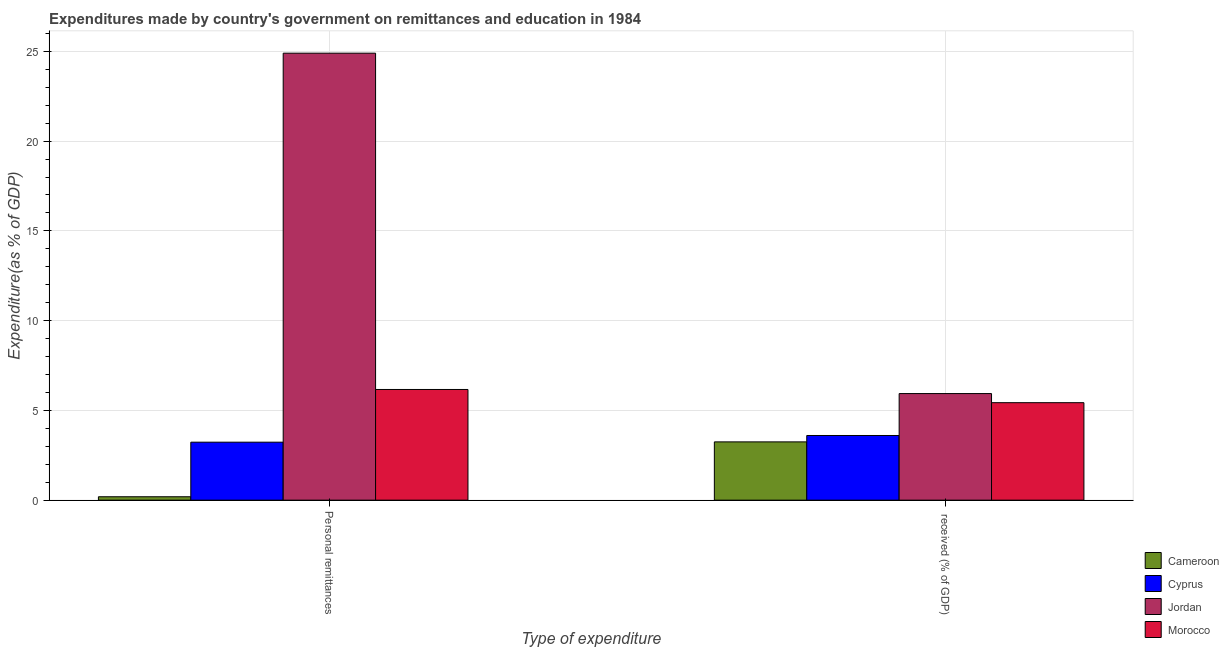Are the number of bars on each tick of the X-axis equal?
Ensure brevity in your answer.  Yes. What is the label of the 2nd group of bars from the left?
Your answer should be compact.  received (% of GDP). What is the expenditure in personal remittances in Jordan?
Offer a terse response. 24.9. Across all countries, what is the maximum expenditure in personal remittances?
Your response must be concise. 24.9. Across all countries, what is the minimum expenditure in personal remittances?
Provide a succinct answer. 0.19. In which country was the expenditure in personal remittances maximum?
Offer a terse response. Jordan. In which country was the expenditure in education minimum?
Offer a very short reply. Cameroon. What is the total expenditure in education in the graph?
Provide a succinct answer. 18.21. What is the difference between the expenditure in education in Cyprus and that in Morocco?
Your response must be concise. -1.83. What is the difference between the expenditure in education in Morocco and the expenditure in personal remittances in Cyprus?
Make the answer very short. 2.2. What is the average expenditure in education per country?
Ensure brevity in your answer.  4.55. What is the difference between the expenditure in personal remittances and expenditure in education in Morocco?
Keep it short and to the point. 0.74. What is the ratio of the expenditure in personal remittances in Cyprus to that in Jordan?
Your answer should be compact. 0.13. Is the expenditure in personal remittances in Cyprus less than that in Morocco?
Make the answer very short. Yes. What does the 1st bar from the left in  received (% of GDP) represents?
Give a very brief answer. Cameroon. What does the 4th bar from the right in Personal remittances represents?
Keep it short and to the point. Cameroon. Are the values on the major ticks of Y-axis written in scientific E-notation?
Your answer should be compact. No. Does the graph contain grids?
Give a very brief answer. Yes. Where does the legend appear in the graph?
Make the answer very short. Bottom right. How are the legend labels stacked?
Keep it short and to the point. Vertical. What is the title of the graph?
Your answer should be very brief. Expenditures made by country's government on remittances and education in 1984. What is the label or title of the X-axis?
Provide a succinct answer. Type of expenditure. What is the label or title of the Y-axis?
Offer a very short reply. Expenditure(as % of GDP). What is the Expenditure(as % of GDP) of Cameroon in Personal remittances?
Provide a succinct answer. 0.19. What is the Expenditure(as % of GDP) of Cyprus in Personal remittances?
Keep it short and to the point. 3.23. What is the Expenditure(as % of GDP) of Jordan in Personal remittances?
Give a very brief answer. 24.9. What is the Expenditure(as % of GDP) in Morocco in Personal remittances?
Provide a succinct answer. 6.17. What is the Expenditure(as % of GDP) in Cameroon in  received (% of GDP)?
Ensure brevity in your answer.  3.25. What is the Expenditure(as % of GDP) of Cyprus in  received (% of GDP)?
Your response must be concise. 3.6. What is the Expenditure(as % of GDP) in Jordan in  received (% of GDP)?
Give a very brief answer. 5.94. What is the Expenditure(as % of GDP) of Morocco in  received (% of GDP)?
Offer a very short reply. 5.43. Across all Type of expenditure, what is the maximum Expenditure(as % of GDP) in Cameroon?
Provide a succinct answer. 3.25. Across all Type of expenditure, what is the maximum Expenditure(as % of GDP) of Cyprus?
Provide a succinct answer. 3.6. Across all Type of expenditure, what is the maximum Expenditure(as % of GDP) of Jordan?
Give a very brief answer. 24.9. Across all Type of expenditure, what is the maximum Expenditure(as % of GDP) in Morocco?
Your response must be concise. 6.17. Across all Type of expenditure, what is the minimum Expenditure(as % of GDP) in Cameroon?
Offer a terse response. 0.19. Across all Type of expenditure, what is the minimum Expenditure(as % of GDP) of Cyprus?
Provide a short and direct response. 3.23. Across all Type of expenditure, what is the minimum Expenditure(as % of GDP) of Jordan?
Keep it short and to the point. 5.94. Across all Type of expenditure, what is the minimum Expenditure(as % of GDP) of Morocco?
Your response must be concise. 5.43. What is the total Expenditure(as % of GDP) in Cameroon in the graph?
Offer a terse response. 3.44. What is the total Expenditure(as % of GDP) of Cyprus in the graph?
Provide a short and direct response. 6.83. What is the total Expenditure(as % of GDP) in Jordan in the graph?
Provide a succinct answer. 30.83. What is the total Expenditure(as % of GDP) in Morocco in the graph?
Provide a succinct answer. 11.6. What is the difference between the Expenditure(as % of GDP) in Cameroon in Personal remittances and that in  received (% of GDP)?
Offer a terse response. -3.06. What is the difference between the Expenditure(as % of GDP) in Cyprus in Personal remittances and that in  received (% of GDP)?
Provide a succinct answer. -0.37. What is the difference between the Expenditure(as % of GDP) in Jordan in Personal remittances and that in  received (% of GDP)?
Ensure brevity in your answer.  18.96. What is the difference between the Expenditure(as % of GDP) in Morocco in Personal remittances and that in  received (% of GDP)?
Provide a short and direct response. 0.74. What is the difference between the Expenditure(as % of GDP) of Cameroon in Personal remittances and the Expenditure(as % of GDP) of Cyprus in  received (% of GDP)?
Offer a very short reply. -3.41. What is the difference between the Expenditure(as % of GDP) in Cameroon in Personal remittances and the Expenditure(as % of GDP) in Jordan in  received (% of GDP)?
Your answer should be very brief. -5.75. What is the difference between the Expenditure(as % of GDP) in Cameroon in Personal remittances and the Expenditure(as % of GDP) in Morocco in  received (% of GDP)?
Offer a very short reply. -5.24. What is the difference between the Expenditure(as % of GDP) in Cyprus in Personal remittances and the Expenditure(as % of GDP) in Jordan in  received (% of GDP)?
Provide a short and direct response. -2.71. What is the difference between the Expenditure(as % of GDP) of Cyprus in Personal remittances and the Expenditure(as % of GDP) of Morocco in  received (% of GDP)?
Offer a very short reply. -2.2. What is the difference between the Expenditure(as % of GDP) of Jordan in Personal remittances and the Expenditure(as % of GDP) of Morocco in  received (% of GDP)?
Offer a terse response. 19.47. What is the average Expenditure(as % of GDP) of Cameroon per Type of expenditure?
Your answer should be compact. 1.72. What is the average Expenditure(as % of GDP) in Cyprus per Type of expenditure?
Your response must be concise. 3.42. What is the average Expenditure(as % of GDP) of Jordan per Type of expenditure?
Provide a short and direct response. 15.42. What is the average Expenditure(as % of GDP) in Morocco per Type of expenditure?
Offer a very short reply. 5.8. What is the difference between the Expenditure(as % of GDP) in Cameroon and Expenditure(as % of GDP) in Cyprus in Personal remittances?
Your response must be concise. -3.04. What is the difference between the Expenditure(as % of GDP) in Cameroon and Expenditure(as % of GDP) in Jordan in Personal remittances?
Give a very brief answer. -24.71. What is the difference between the Expenditure(as % of GDP) of Cameroon and Expenditure(as % of GDP) of Morocco in Personal remittances?
Your answer should be compact. -5.98. What is the difference between the Expenditure(as % of GDP) of Cyprus and Expenditure(as % of GDP) of Jordan in Personal remittances?
Your answer should be very brief. -21.67. What is the difference between the Expenditure(as % of GDP) of Cyprus and Expenditure(as % of GDP) of Morocco in Personal remittances?
Offer a very short reply. -2.94. What is the difference between the Expenditure(as % of GDP) in Jordan and Expenditure(as % of GDP) in Morocco in Personal remittances?
Offer a terse response. 18.73. What is the difference between the Expenditure(as % of GDP) in Cameroon and Expenditure(as % of GDP) in Cyprus in  received (% of GDP)?
Provide a short and direct response. -0.36. What is the difference between the Expenditure(as % of GDP) in Cameroon and Expenditure(as % of GDP) in Jordan in  received (% of GDP)?
Your answer should be very brief. -2.69. What is the difference between the Expenditure(as % of GDP) of Cameroon and Expenditure(as % of GDP) of Morocco in  received (% of GDP)?
Give a very brief answer. -2.18. What is the difference between the Expenditure(as % of GDP) of Cyprus and Expenditure(as % of GDP) of Jordan in  received (% of GDP)?
Ensure brevity in your answer.  -2.33. What is the difference between the Expenditure(as % of GDP) in Cyprus and Expenditure(as % of GDP) in Morocco in  received (% of GDP)?
Your answer should be compact. -1.83. What is the difference between the Expenditure(as % of GDP) of Jordan and Expenditure(as % of GDP) of Morocco in  received (% of GDP)?
Offer a very short reply. 0.51. What is the ratio of the Expenditure(as % of GDP) of Cameroon in Personal remittances to that in  received (% of GDP)?
Offer a terse response. 0.06. What is the ratio of the Expenditure(as % of GDP) in Cyprus in Personal remittances to that in  received (% of GDP)?
Provide a short and direct response. 0.9. What is the ratio of the Expenditure(as % of GDP) of Jordan in Personal remittances to that in  received (% of GDP)?
Your response must be concise. 4.19. What is the ratio of the Expenditure(as % of GDP) of Morocco in Personal remittances to that in  received (% of GDP)?
Give a very brief answer. 1.14. What is the difference between the highest and the second highest Expenditure(as % of GDP) in Cameroon?
Your response must be concise. 3.06. What is the difference between the highest and the second highest Expenditure(as % of GDP) of Cyprus?
Your answer should be compact. 0.37. What is the difference between the highest and the second highest Expenditure(as % of GDP) in Jordan?
Make the answer very short. 18.96. What is the difference between the highest and the second highest Expenditure(as % of GDP) in Morocco?
Offer a very short reply. 0.74. What is the difference between the highest and the lowest Expenditure(as % of GDP) in Cameroon?
Your answer should be compact. 3.06. What is the difference between the highest and the lowest Expenditure(as % of GDP) in Cyprus?
Offer a very short reply. 0.37. What is the difference between the highest and the lowest Expenditure(as % of GDP) of Jordan?
Offer a very short reply. 18.96. What is the difference between the highest and the lowest Expenditure(as % of GDP) in Morocco?
Offer a terse response. 0.74. 